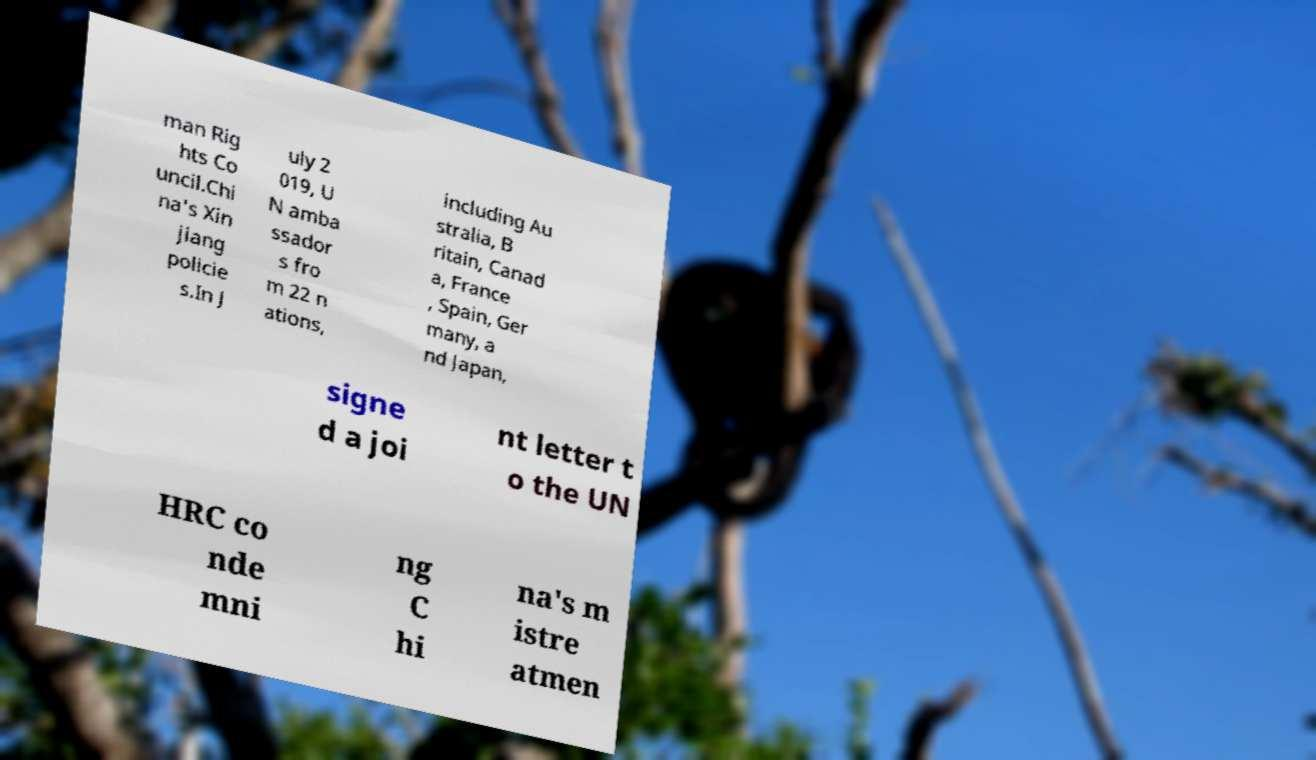What messages or text are displayed in this image? I need them in a readable, typed format. man Rig hts Co uncil.Chi na's Xin jiang policie s.In J uly 2 019, U N amba ssador s fro m 22 n ations, including Au stralia, B ritain, Canad a, France , Spain, Ger many, a nd Japan, signe d a joi nt letter t o the UN HRC co nde mni ng C hi na's m istre atmen 